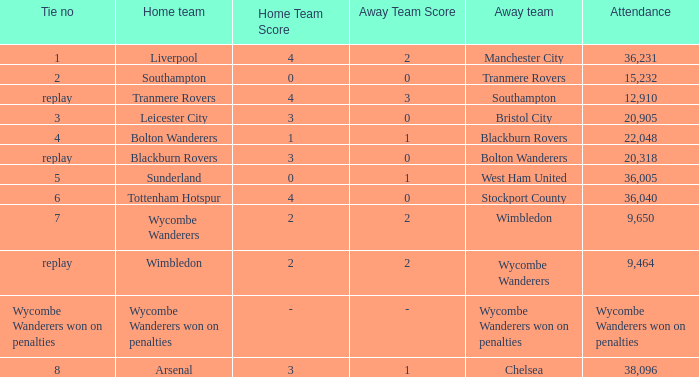Help me parse the entirety of this table. {'header': ['Tie no', 'Home team', 'Home Team Score', 'Away Team Score', 'Away team', 'Attendance'], 'rows': [['1', 'Liverpool', '4', '2', 'Manchester City', '36,231'], ['2', 'Southampton', '0', '0', 'Tranmere Rovers', '15,232'], ['replay', 'Tranmere Rovers', '4', '3', 'Southampton', '12,910'], ['3', 'Leicester City', '3', '0', 'Bristol City', '20,905'], ['4', 'Bolton Wanderers', '1', '1', 'Blackburn Rovers', '22,048'], ['replay', 'Blackburn Rovers', '3', '0', 'Bolton Wanderers', '20,318'], ['5', 'Sunderland', '0', '1', 'West Ham United', '36,005'], ['6', 'Tottenham Hotspur', '4', '0', 'Stockport County', '36,040'], ['7', 'Wycombe Wanderers', '2', '2', 'Wimbledon', '9,650'], ['replay', 'Wimbledon', '2', '2', 'Wycombe Wanderers', '9,464'], ['Wycombe Wanderers won on penalties', 'Wycombe Wanderers won on penalties', '-', '-', 'Wycombe Wanderers won on penalties', 'Wycombe Wanderers won on penalties'], ['8', 'Arsenal', '3', '1', 'Chelsea', '38,096']]} What was the score of having a tie of 1? 4 – 2. 